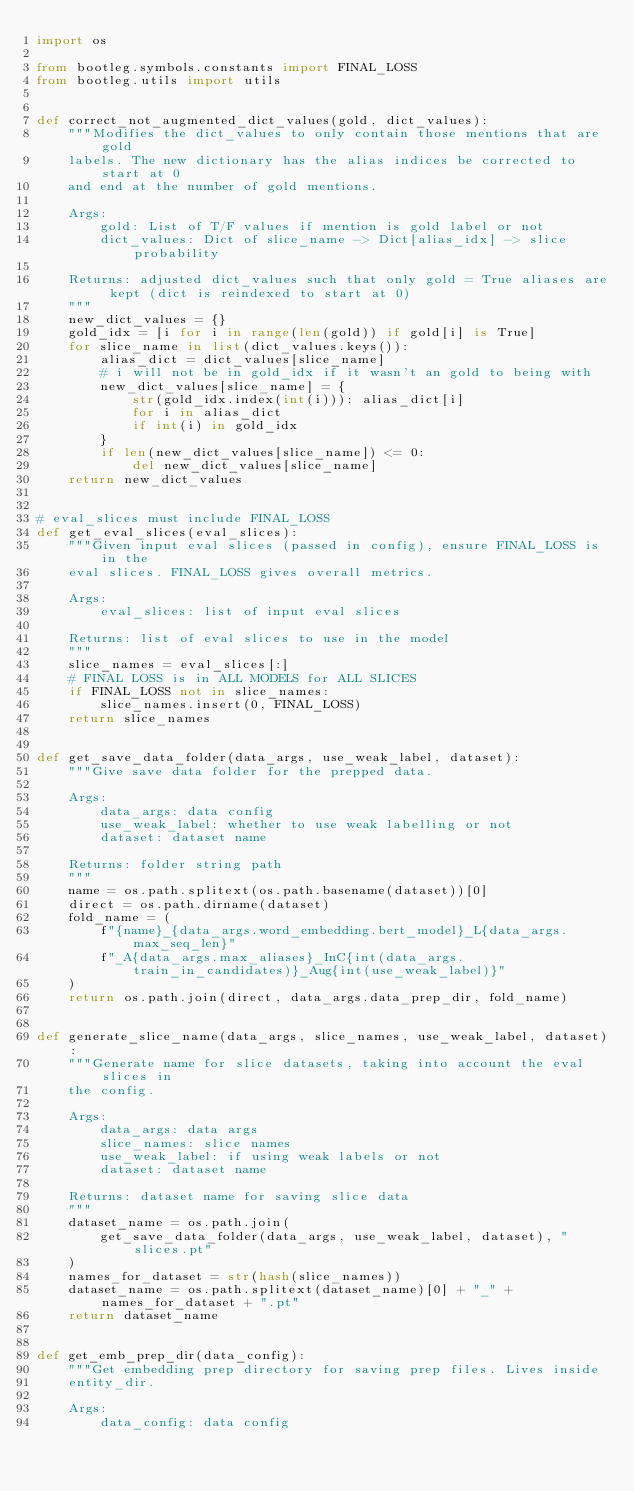Convert code to text. <code><loc_0><loc_0><loc_500><loc_500><_Python_>import os

from bootleg.symbols.constants import FINAL_LOSS
from bootleg.utils import utils


def correct_not_augmented_dict_values(gold, dict_values):
    """Modifies the dict_values to only contain those mentions that are gold
    labels. The new dictionary has the alias indices be corrected to start at 0
    and end at the number of gold mentions.

    Args:
        gold: List of T/F values if mention is gold label or not
        dict_values: Dict of slice_name -> Dict[alias_idx] -> slice probability

    Returns: adjusted dict_values such that only gold = True aliases are kept (dict is reindexed to start at 0)
    """
    new_dict_values = {}
    gold_idx = [i for i in range(len(gold)) if gold[i] is True]
    for slice_name in list(dict_values.keys()):
        alias_dict = dict_values[slice_name]
        # i will not be in gold_idx if it wasn't an gold to being with
        new_dict_values[slice_name] = {
            str(gold_idx.index(int(i))): alias_dict[i]
            for i in alias_dict
            if int(i) in gold_idx
        }
        if len(new_dict_values[slice_name]) <= 0:
            del new_dict_values[slice_name]
    return new_dict_values


# eval_slices must include FINAL_LOSS
def get_eval_slices(eval_slices):
    """Given input eval slices (passed in config), ensure FINAL_LOSS is in the
    eval slices. FINAL_LOSS gives overall metrics.

    Args:
        eval_slices: list of input eval slices

    Returns: list of eval slices to use in the model
    """
    slice_names = eval_slices[:]
    # FINAL LOSS is in ALL MODELS for ALL SLICES
    if FINAL_LOSS not in slice_names:
        slice_names.insert(0, FINAL_LOSS)
    return slice_names


def get_save_data_folder(data_args, use_weak_label, dataset):
    """Give save data folder for the prepped data.

    Args:
        data_args: data config
        use_weak_label: whether to use weak labelling or not
        dataset: dataset name

    Returns: folder string path
    """
    name = os.path.splitext(os.path.basename(dataset))[0]
    direct = os.path.dirname(dataset)
    fold_name = (
        f"{name}_{data_args.word_embedding.bert_model}_L{data_args.max_seq_len}"
        f"_A{data_args.max_aliases}_InC{int(data_args.train_in_candidates)}_Aug{int(use_weak_label)}"
    )
    return os.path.join(direct, data_args.data_prep_dir, fold_name)


def generate_slice_name(data_args, slice_names, use_weak_label, dataset):
    """Generate name for slice datasets, taking into account the eval slices in
    the config.

    Args:
        data_args: data args
        slice_names: slice names
        use_weak_label: if using weak labels or not
        dataset: dataset name

    Returns: dataset name for saving slice data
    """
    dataset_name = os.path.join(
        get_save_data_folder(data_args, use_weak_label, dataset), "slices.pt"
    )
    names_for_dataset = str(hash(slice_names))
    dataset_name = os.path.splitext(dataset_name)[0] + "_" + names_for_dataset + ".pt"
    return dataset_name


def get_emb_prep_dir(data_config):
    """Get embedding prep directory for saving prep files. Lives inside
    entity_dir.

    Args:
        data_config: data config
</code> 